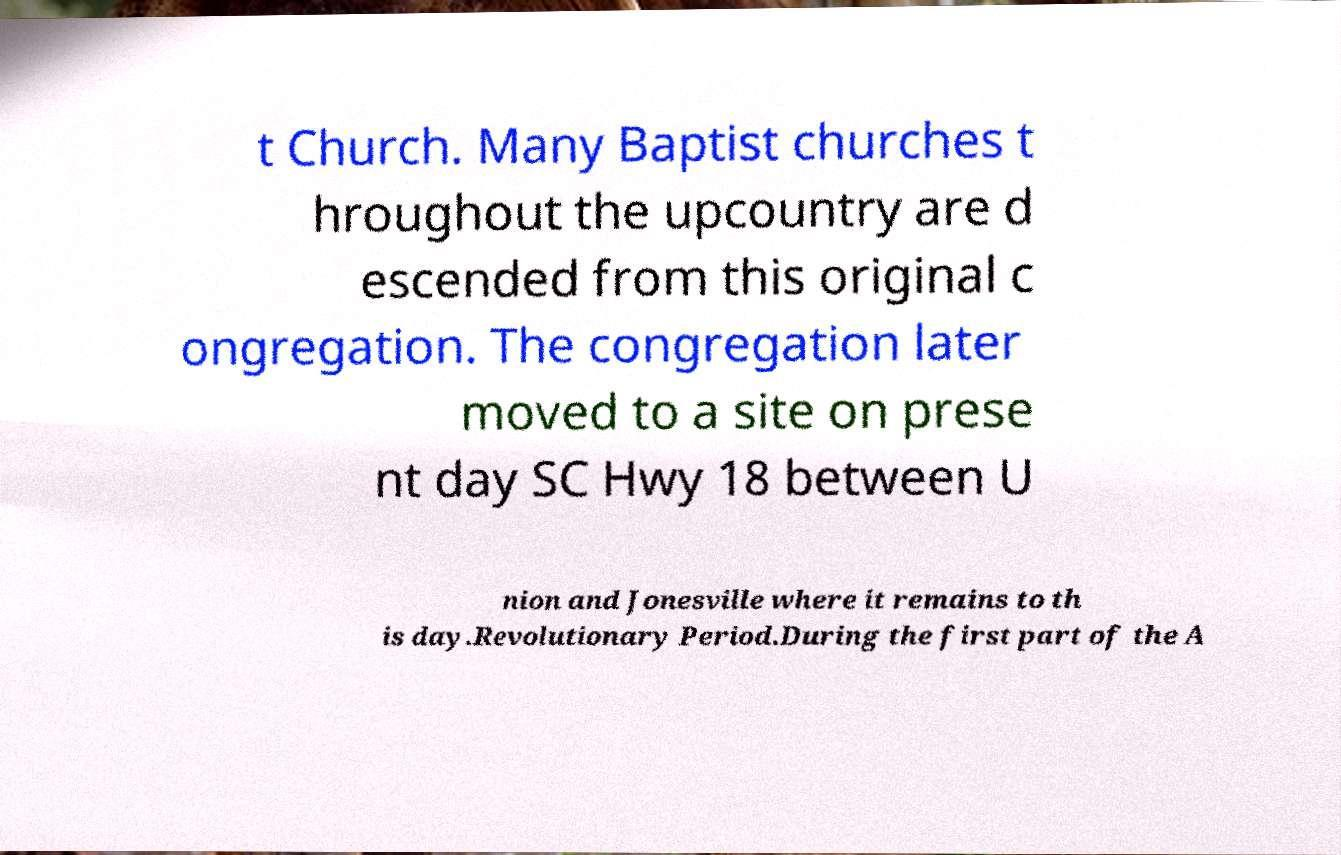Could you assist in decoding the text presented in this image and type it out clearly? t Church. Many Baptist churches t hroughout the upcountry are d escended from this original c ongregation. The congregation later moved to a site on prese nt day SC Hwy 18 between U nion and Jonesville where it remains to th is day.Revolutionary Period.During the first part of the A 